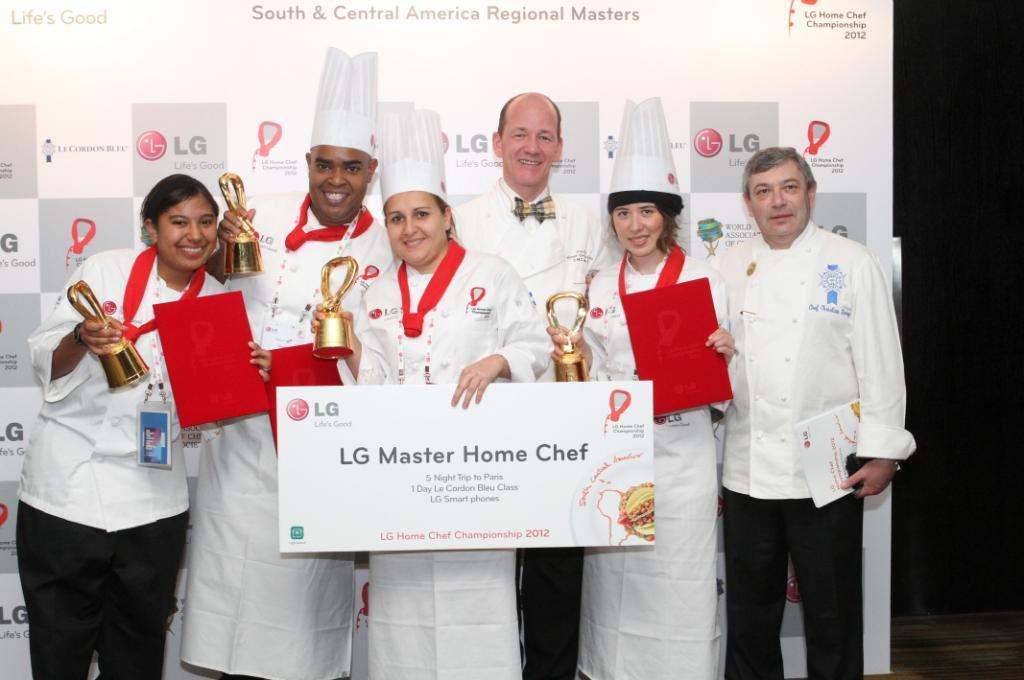How would you summarize this image in a sentence or two? In this image I can see there are six persons and they are wearing a white color jackets and holding the metal cups and hoarding boards and red color papers and in the background I can see a hoarding board and persons are smiling 